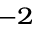<formula> <loc_0><loc_0><loc_500><loc_500>^ { - 2 }</formula> 